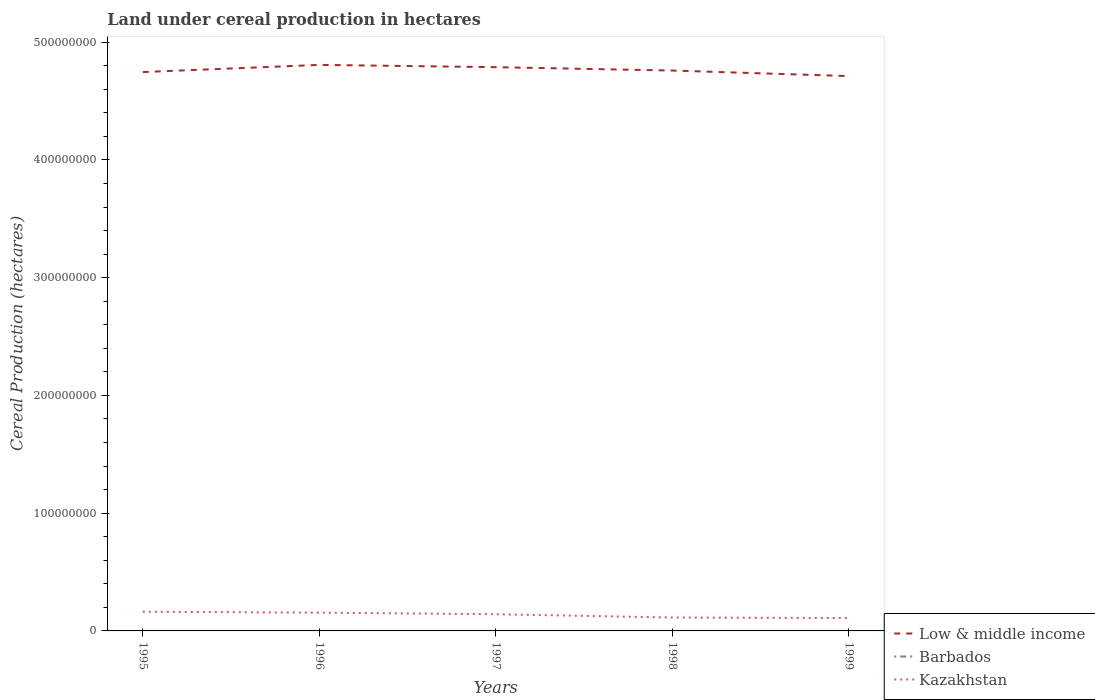Is the number of lines equal to the number of legend labels?
Ensure brevity in your answer.  Yes. Across all years, what is the maximum land under cereal production in Low & middle income?
Keep it short and to the point. 4.71e+08. What is the total land under cereal production in Barbados in the graph?
Give a very brief answer. 100. What is the difference between the highest and the second highest land under cereal production in Kazakhstan?
Keep it short and to the point. 5.39e+06. What is the difference between the highest and the lowest land under cereal production in Barbados?
Your answer should be very brief. 2. What is the difference between two consecutive major ticks on the Y-axis?
Provide a succinct answer. 1.00e+08. Does the graph contain any zero values?
Make the answer very short. No. Does the graph contain grids?
Offer a very short reply. No. Where does the legend appear in the graph?
Make the answer very short. Bottom right. How many legend labels are there?
Your response must be concise. 3. How are the legend labels stacked?
Offer a very short reply. Vertical. What is the title of the graph?
Provide a succinct answer. Land under cereal production in hectares. What is the label or title of the Y-axis?
Provide a succinct answer. Cereal Production (hectares). What is the Cereal Production (hectares) in Low & middle income in 1995?
Your answer should be compact. 4.75e+08. What is the Cereal Production (hectares) in Kazakhstan in 1995?
Offer a very short reply. 1.63e+07. What is the Cereal Production (hectares) in Low & middle income in 1996?
Make the answer very short. 4.81e+08. What is the Cereal Production (hectares) of Barbados in 1996?
Give a very brief answer. 300. What is the Cereal Production (hectares) in Kazakhstan in 1996?
Provide a succinct answer. 1.55e+07. What is the Cereal Production (hectares) in Low & middle income in 1997?
Your answer should be compact. 4.79e+08. What is the Cereal Production (hectares) of Barbados in 1997?
Your answer should be compact. 250. What is the Cereal Production (hectares) in Kazakhstan in 1997?
Offer a terse response. 1.42e+07. What is the Cereal Production (hectares) in Low & middle income in 1998?
Your response must be concise. 4.76e+08. What is the Cereal Production (hectares) of Kazakhstan in 1998?
Make the answer very short. 1.14e+07. What is the Cereal Production (hectares) of Low & middle income in 1999?
Your response must be concise. 4.71e+08. What is the Cereal Production (hectares) of Barbados in 1999?
Keep it short and to the point. 150. What is the Cereal Production (hectares) in Kazakhstan in 1999?
Provide a short and direct response. 1.09e+07. Across all years, what is the maximum Cereal Production (hectares) in Low & middle income?
Give a very brief answer. 4.81e+08. Across all years, what is the maximum Cereal Production (hectares) in Barbados?
Your response must be concise. 400. Across all years, what is the maximum Cereal Production (hectares) in Kazakhstan?
Make the answer very short. 1.63e+07. Across all years, what is the minimum Cereal Production (hectares) of Low & middle income?
Your answer should be very brief. 4.71e+08. Across all years, what is the minimum Cereal Production (hectares) of Barbados?
Your answer should be compact. 150. Across all years, what is the minimum Cereal Production (hectares) of Kazakhstan?
Provide a succinct answer. 1.09e+07. What is the total Cereal Production (hectares) in Low & middle income in the graph?
Make the answer very short. 2.38e+09. What is the total Cereal Production (hectares) in Barbados in the graph?
Offer a terse response. 1300. What is the total Cereal Production (hectares) of Kazakhstan in the graph?
Make the answer very short. 6.83e+07. What is the difference between the Cereal Production (hectares) in Low & middle income in 1995 and that in 1996?
Your answer should be compact. -6.10e+06. What is the difference between the Cereal Production (hectares) in Kazakhstan in 1995 and that in 1996?
Keep it short and to the point. 8.10e+05. What is the difference between the Cereal Production (hectares) of Low & middle income in 1995 and that in 1997?
Offer a very short reply. -4.15e+06. What is the difference between the Cereal Production (hectares) in Barbados in 1995 and that in 1997?
Your answer should be compact. 150. What is the difference between the Cereal Production (hectares) in Kazakhstan in 1995 and that in 1997?
Provide a short and direct response. 2.13e+06. What is the difference between the Cereal Production (hectares) in Low & middle income in 1995 and that in 1998?
Your answer should be very brief. -1.29e+06. What is the difference between the Cereal Production (hectares) in Barbados in 1995 and that in 1998?
Your response must be concise. 200. What is the difference between the Cereal Production (hectares) in Kazakhstan in 1995 and that in 1998?
Make the answer very short. 4.95e+06. What is the difference between the Cereal Production (hectares) of Low & middle income in 1995 and that in 1999?
Your response must be concise. 3.41e+06. What is the difference between the Cereal Production (hectares) of Barbados in 1995 and that in 1999?
Keep it short and to the point. 250. What is the difference between the Cereal Production (hectares) in Kazakhstan in 1995 and that in 1999?
Offer a very short reply. 5.39e+06. What is the difference between the Cereal Production (hectares) of Low & middle income in 1996 and that in 1997?
Your response must be concise. 1.95e+06. What is the difference between the Cereal Production (hectares) in Barbados in 1996 and that in 1997?
Give a very brief answer. 50. What is the difference between the Cereal Production (hectares) of Kazakhstan in 1996 and that in 1997?
Provide a succinct answer. 1.32e+06. What is the difference between the Cereal Production (hectares) of Low & middle income in 1996 and that in 1998?
Give a very brief answer. 4.81e+06. What is the difference between the Cereal Production (hectares) of Barbados in 1996 and that in 1998?
Ensure brevity in your answer.  100. What is the difference between the Cereal Production (hectares) in Kazakhstan in 1996 and that in 1998?
Offer a terse response. 4.14e+06. What is the difference between the Cereal Production (hectares) in Low & middle income in 1996 and that in 1999?
Offer a very short reply. 9.52e+06. What is the difference between the Cereal Production (hectares) of Barbados in 1996 and that in 1999?
Your response must be concise. 150. What is the difference between the Cereal Production (hectares) in Kazakhstan in 1996 and that in 1999?
Your response must be concise. 4.58e+06. What is the difference between the Cereal Production (hectares) of Low & middle income in 1997 and that in 1998?
Provide a succinct answer. 2.86e+06. What is the difference between the Cereal Production (hectares) of Kazakhstan in 1997 and that in 1998?
Your response must be concise. 2.81e+06. What is the difference between the Cereal Production (hectares) in Low & middle income in 1997 and that in 1999?
Keep it short and to the point. 7.57e+06. What is the difference between the Cereal Production (hectares) of Kazakhstan in 1997 and that in 1999?
Your response must be concise. 3.26e+06. What is the difference between the Cereal Production (hectares) of Low & middle income in 1998 and that in 1999?
Your response must be concise. 4.71e+06. What is the difference between the Cereal Production (hectares) of Barbados in 1998 and that in 1999?
Give a very brief answer. 50. What is the difference between the Cereal Production (hectares) in Kazakhstan in 1998 and that in 1999?
Provide a short and direct response. 4.42e+05. What is the difference between the Cereal Production (hectares) of Low & middle income in 1995 and the Cereal Production (hectares) of Barbados in 1996?
Offer a terse response. 4.75e+08. What is the difference between the Cereal Production (hectares) in Low & middle income in 1995 and the Cereal Production (hectares) in Kazakhstan in 1996?
Offer a terse response. 4.59e+08. What is the difference between the Cereal Production (hectares) of Barbados in 1995 and the Cereal Production (hectares) of Kazakhstan in 1996?
Offer a terse response. -1.55e+07. What is the difference between the Cereal Production (hectares) of Low & middle income in 1995 and the Cereal Production (hectares) of Barbados in 1997?
Your response must be concise. 4.75e+08. What is the difference between the Cereal Production (hectares) in Low & middle income in 1995 and the Cereal Production (hectares) in Kazakhstan in 1997?
Make the answer very short. 4.60e+08. What is the difference between the Cereal Production (hectares) of Barbados in 1995 and the Cereal Production (hectares) of Kazakhstan in 1997?
Your response must be concise. -1.42e+07. What is the difference between the Cereal Production (hectares) of Low & middle income in 1995 and the Cereal Production (hectares) of Barbados in 1998?
Ensure brevity in your answer.  4.75e+08. What is the difference between the Cereal Production (hectares) in Low & middle income in 1995 and the Cereal Production (hectares) in Kazakhstan in 1998?
Your answer should be very brief. 4.63e+08. What is the difference between the Cereal Production (hectares) of Barbados in 1995 and the Cereal Production (hectares) of Kazakhstan in 1998?
Your answer should be compact. -1.14e+07. What is the difference between the Cereal Production (hectares) in Low & middle income in 1995 and the Cereal Production (hectares) in Barbados in 1999?
Ensure brevity in your answer.  4.75e+08. What is the difference between the Cereal Production (hectares) of Low & middle income in 1995 and the Cereal Production (hectares) of Kazakhstan in 1999?
Your answer should be very brief. 4.64e+08. What is the difference between the Cereal Production (hectares) in Barbados in 1995 and the Cereal Production (hectares) in Kazakhstan in 1999?
Your response must be concise. -1.09e+07. What is the difference between the Cereal Production (hectares) in Low & middle income in 1996 and the Cereal Production (hectares) in Barbados in 1997?
Your answer should be compact. 4.81e+08. What is the difference between the Cereal Production (hectares) in Low & middle income in 1996 and the Cereal Production (hectares) in Kazakhstan in 1997?
Your answer should be very brief. 4.67e+08. What is the difference between the Cereal Production (hectares) of Barbados in 1996 and the Cereal Production (hectares) of Kazakhstan in 1997?
Your answer should be compact. -1.42e+07. What is the difference between the Cereal Production (hectares) of Low & middle income in 1996 and the Cereal Production (hectares) of Barbados in 1998?
Provide a succinct answer. 4.81e+08. What is the difference between the Cereal Production (hectares) in Low & middle income in 1996 and the Cereal Production (hectares) in Kazakhstan in 1998?
Provide a succinct answer. 4.69e+08. What is the difference between the Cereal Production (hectares) of Barbados in 1996 and the Cereal Production (hectares) of Kazakhstan in 1998?
Ensure brevity in your answer.  -1.14e+07. What is the difference between the Cereal Production (hectares) of Low & middle income in 1996 and the Cereal Production (hectares) of Barbados in 1999?
Give a very brief answer. 4.81e+08. What is the difference between the Cereal Production (hectares) of Low & middle income in 1996 and the Cereal Production (hectares) of Kazakhstan in 1999?
Offer a terse response. 4.70e+08. What is the difference between the Cereal Production (hectares) in Barbados in 1996 and the Cereal Production (hectares) in Kazakhstan in 1999?
Your answer should be compact. -1.09e+07. What is the difference between the Cereal Production (hectares) in Low & middle income in 1997 and the Cereal Production (hectares) in Barbados in 1998?
Provide a short and direct response. 4.79e+08. What is the difference between the Cereal Production (hectares) of Low & middle income in 1997 and the Cereal Production (hectares) of Kazakhstan in 1998?
Your response must be concise. 4.67e+08. What is the difference between the Cereal Production (hectares) of Barbados in 1997 and the Cereal Production (hectares) of Kazakhstan in 1998?
Your answer should be compact. -1.14e+07. What is the difference between the Cereal Production (hectares) of Low & middle income in 1997 and the Cereal Production (hectares) of Barbados in 1999?
Provide a succinct answer. 4.79e+08. What is the difference between the Cereal Production (hectares) of Low & middle income in 1997 and the Cereal Production (hectares) of Kazakhstan in 1999?
Give a very brief answer. 4.68e+08. What is the difference between the Cereal Production (hectares) in Barbados in 1997 and the Cereal Production (hectares) in Kazakhstan in 1999?
Your answer should be very brief. -1.09e+07. What is the difference between the Cereal Production (hectares) of Low & middle income in 1998 and the Cereal Production (hectares) of Barbados in 1999?
Your response must be concise. 4.76e+08. What is the difference between the Cereal Production (hectares) of Low & middle income in 1998 and the Cereal Production (hectares) of Kazakhstan in 1999?
Provide a short and direct response. 4.65e+08. What is the difference between the Cereal Production (hectares) of Barbados in 1998 and the Cereal Production (hectares) of Kazakhstan in 1999?
Offer a terse response. -1.09e+07. What is the average Cereal Production (hectares) of Low & middle income per year?
Offer a terse response. 4.76e+08. What is the average Cereal Production (hectares) in Barbados per year?
Your answer should be compact. 260. What is the average Cereal Production (hectares) in Kazakhstan per year?
Provide a succinct answer. 1.37e+07. In the year 1995, what is the difference between the Cereal Production (hectares) in Low & middle income and Cereal Production (hectares) in Barbados?
Ensure brevity in your answer.  4.75e+08. In the year 1995, what is the difference between the Cereal Production (hectares) in Low & middle income and Cereal Production (hectares) in Kazakhstan?
Your answer should be compact. 4.58e+08. In the year 1995, what is the difference between the Cereal Production (hectares) of Barbados and Cereal Production (hectares) of Kazakhstan?
Make the answer very short. -1.63e+07. In the year 1996, what is the difference between the Cereal Production (hectares) of Low & middle income and Cereal Production (hectares) of Barbados?
Ensure brevity in your answer.  4.81e+08. In the year 1996, what is the difference between the Cereal Production (hectares) in Low & middle income and Cereal Production (hectares) in Kazakhstan?
Your answer should be compact. 4.65e+08. In the year 1996, what is the difference between the Cereal Production (hectares) of Barbados and Cereal Production (hectares) of Kazakhstan?
Make the answer very short. -1.55e+07. In the year 1997, what is the difference between the Cereal Production (hectares) of Low & middle income and Cereal Production (hectares) of Barbados?
Make the answer very short. 4.79e+08. In the year 1997, what is the difference between the Cereal Production (hectares) in Low & middle income and Cereal Production (hectares) in Kazakhstan?
Your answer should be very brief. 4.65e+08. In the year 1997, what is the difference between the Cereal Production (hectares) of Barbados and Cereal Production (hectares) of Kazakhstan?
Make the answer very short. -1.42e+07. In the year 1998, what is the difference between the Cereal Production (hectares) of Low & middle income and Cereal Production (hectares) of Barbados?
Offer a terse response. 4.76e+08. In the year 1998, what is the difference between the Cereal Production (hectares) of Low & middle income and Cereal Production (hectares) of Kazakhstan?
Your response must be concise. 4.65e+08. In the year 1998, what is the difference between the Cereal Production (hectares) of Barbados and Cereal Production (hectares) of Kazakhstan?
Ensure brevity in your answer.  -1.14e+07. In the year 1999, what is the difference between the Cereal Production (hectares) in Low & middle income and Cereal Production (hectares) in Barbados?
Ensure brevity in your answer.  4.71e+08. In the year 1999, what is the difference between the Cereal Production (hectares) of Low & middle income and Cereal Production (hectares) of Kazakhstan?
Your answer should be very brief. 4.60e+08. In the year 1999, what is the difference between the Cereal Production (hectares) in Barbados and Cereal Production (hectares) in Kazakhstan?
Offer a very short reply. -1.09e+07. What is the ratio of the Cereal Production (hectares) of Low & middle income in 1995 to that in 1996?
Your answer should be very brief. 0.99. What is the ratio of the Cereal Production (hectares) of Barbados in 1995 to that in 1996?
Make the answer very short. 1.33. What is the ratio of the Cereal Production (hectares) in Kazakhstan in 1995 to that in 1996?
Keep it short and to the point. 1.05. What is the ratio of the Cereal Production (hectares) of Low & middle income in 1995 to that in 1997?
Make the answer very short. 0.99. What is the ratio of the Cereal Production (hectares) of Kazakhstan in 1995 to that in 1997?
Provide a short and direct response. 1.15. What is the ratio of the Cereal Production (hectares) of Low & middle income in 1995 to that in 1998?
Your answer should be compact. 1. What is the ratio of the Cereal Production (hectares) of Barbados in 1995 to that in 1998?
Keep it short and to the point. 2. What is the ratio of the Cereal Production (hectares) of Kazakhstan in 1995 to that in 1998?
Provide a short and direct response. 1.44. What is the ratio of the Cereal Production (hectares) in Low & middle income in 1995 to that in 1999?
Provide a succinct answer. 1.01. What is the ratio of the Cereal Production (hectares) in Barbados in 1995 to that in 1999?
Provide a short and direct response. 2.67. What is the ratio of the Cereal Production (hectares) in Kazakhstan in 1995 to that in 1999?
Make the answer very short. 1.49. What is the ratio of the Cereal Production (hectares) of Low & middle income in 1996 to that in 1997?
Offer a terse response. 1. What is the ratio of the Cereal Production (hectares) of Barbados in 1996 to that in 1997?
Offer a terse response. 1.2. What is the ratio of the Cereal Production (hectares) in Kazakhstan in 1996 to that in 1997?
Your answer should be compact. 1.09. What is the ratio of the Cereal Production (hectares) in Kazakhstan in 1996 to that in 1998?
Your answer should be very brief. 1.36. What is the ratio of the Cereal Production (hectares) of Low & middle income in 1996 to that in 1999?
Provide a short and direct response. 1.02. What is the ratio of the Cereal Production (hectares) of Barbados in 1996 to that in 1999?
Keep it short and to the point. 2. What is the ratio of the Cereal Production (hectares) in Kazakhstan in 1996 to that in 1999?
Your response must be concise. 1.42. What is the ratio of the Cereal Production (hectares) in Barbados in 1997 to that in 1998?
Offer a terse response. 1.25. What is the ratio of the Cereal Production (hectares) of Kazakhstan in 1997 to that in 1998?
Provide a short and direct response. 1.25. What is the ratio of the Cereal Production (hectares) in Low & middle income in 1997 to that in 1999?
Keep it short and to the point. 1.02. What is the ratio of the Cereal Production (hectares) of Barbados in 1997 to that in 1999?
Offer a terse response. 1.67. What is the ratio of the Cereal Production (hectares) in Kazakhstan in 1997 to that in 1999?
Offer a very short reply. 1.3. What is the ratio of the Cereal Production (hectares) in Low & middle income in 1998 to that in 1999?
Your response must be concise. 1.01. What is the ratio of the Cereal Production (hectares) of Barbados in 1998 to that in 1999?
Your response must be concise. 1.33. What is the ratio of the Cereal Production (hectares) of Kazakhstan in 1998 to that in 1999?
Offer a very short reply. 1.04. What is the difference between the highest and the second highest Cereal Production (hectares) in Low & middle income?
Make the answer very short. 1.95e+06. What is the difference between the highest and the second highest Cereal Production (hectares) in Barbados?
Your answer should be very brief. 100. What is the difference between the highest and the second highest Cereal Production (hectares) of Kazakhstan?
Ensure brevity in your answer.  8.10e+05. What is the difference between the highest and the lowest Cereal Production (hectares) in Low & middle income?
Ensure brevity in your answer.  9.52e+06. What is the difference between the highest and the lowest Cereal Production (hectares) of Barbados?
Provide a succinct answer. 250. What is the difference between the highest and the lowest Cereal Production (hectares) of Kazakhstan?
Provide a short and direct response. 5.39e+06. 